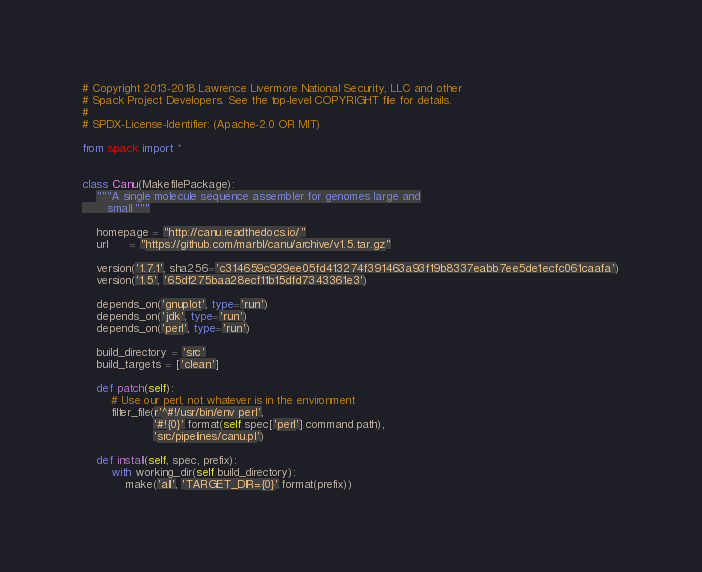<code> <loc_0><loc_0><loc_500><loc_500><_Python_># Copyright 2013-2018 Lawrence Livermore National Security, LLC and other
# Spack Project Developers. See the top-level COPYRIGHT file for details.
#
# SPDX-License-Identifier: (Apache-2.0 OR MIT)

from spack import *


class Canu(MakefilePackage):
    """A single molecule sequence assembler for genomes large and
       small."""

    homepage = "http://canu.readthedocs.io/"
    url      = "https://github.com/marbl/canu/archive/v1.5.tar.gz"

    version('1.7.1', sha256='c314659c929ee05fd413274f391463a93f19b8337eabb7ee5de1ecfc061caafa')
    version('1.5', '65df275baa28ecf11b15dfd7343361e3')

    depends_on('gnuplot', type='run')
    depends_on('jdk', type='run')
    depends_on('perl', type='run')

    build_directory = 'src'
    build_targets = ['clean']

    def patch(self):
        # Use our perl, not whatever is in the environment
        filter_file(r'^#!/usr/bin/env perl',
                    '#!{0}'.format(self.spec['perl'].command.path),
                    'src/pipelines/canu.pl')

    def install(self, spec, prefix):
        with working_dir(self.build_directory):
            make('all', 'TARGET_DIR={0}'.format(prefix))
</code> 